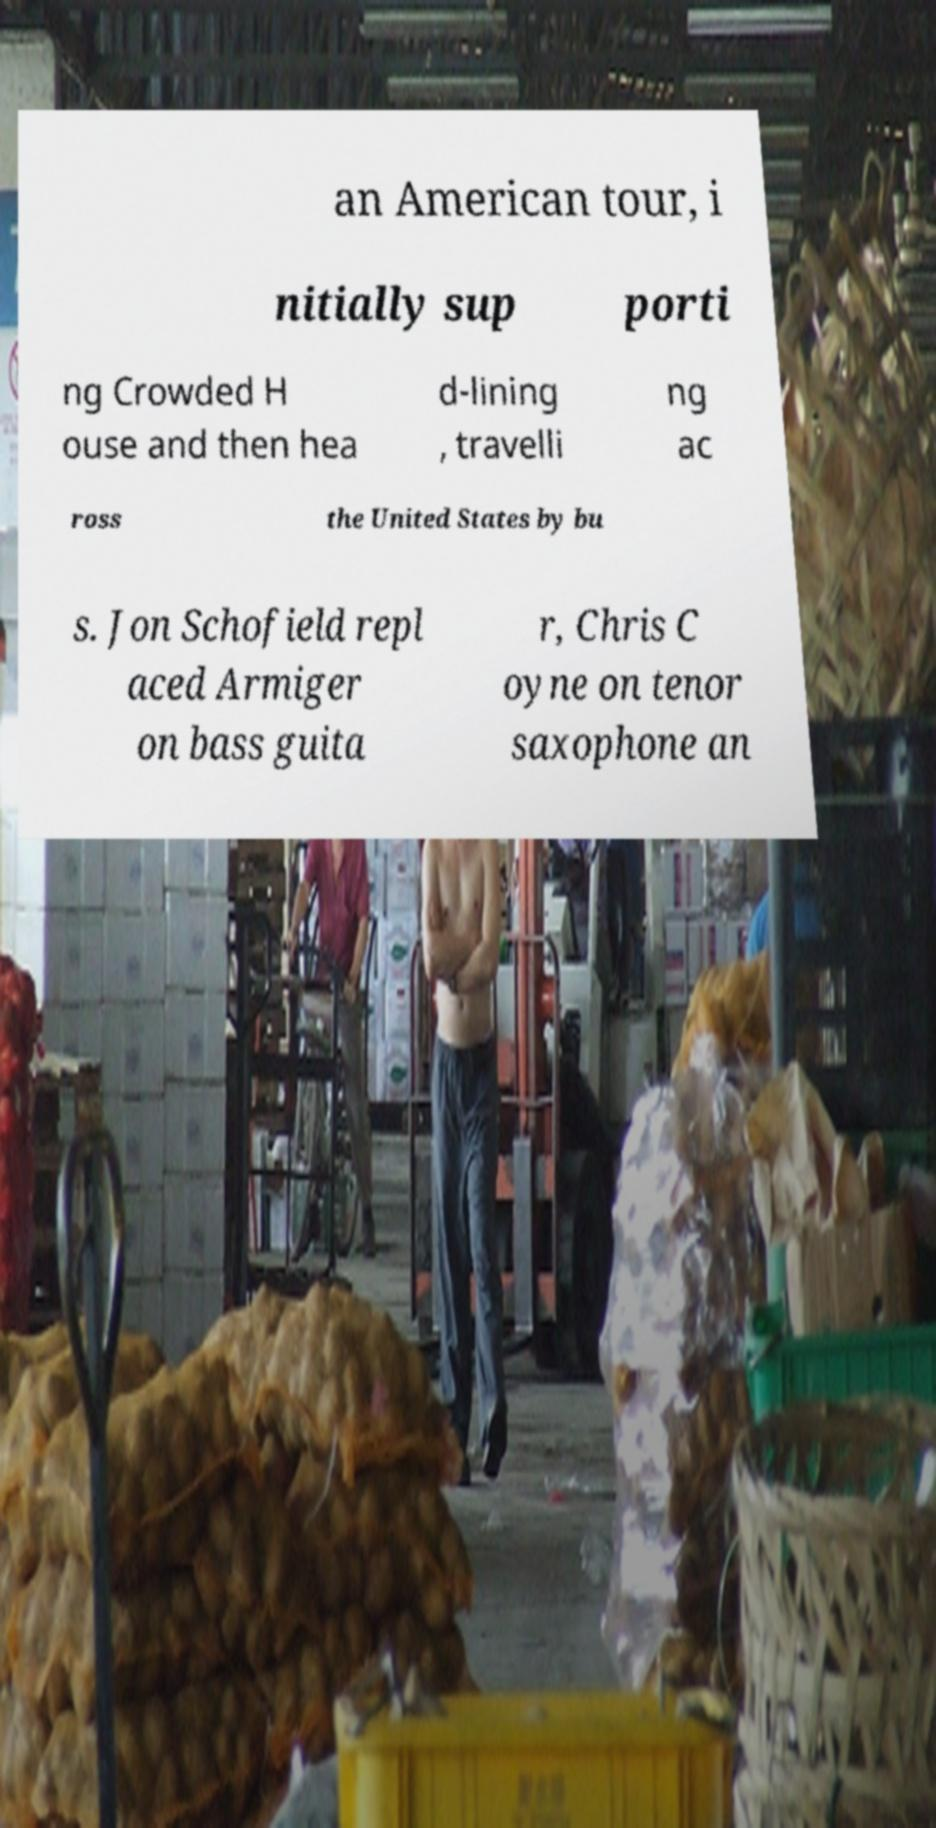Could you extract and type out the text from this image? an American tour, i nitially sup porti ng Crowded H ouse and then hea d-lining , travelli ng ac ross the United States by bu s. Jon Schofield repl aced Armiger on bass guita r, Chris C oyne on tenor saxophone an 